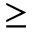Convert formula to latex. <formula><loc_0><loc_0><loc_500><loc_500>\geq</formula> 